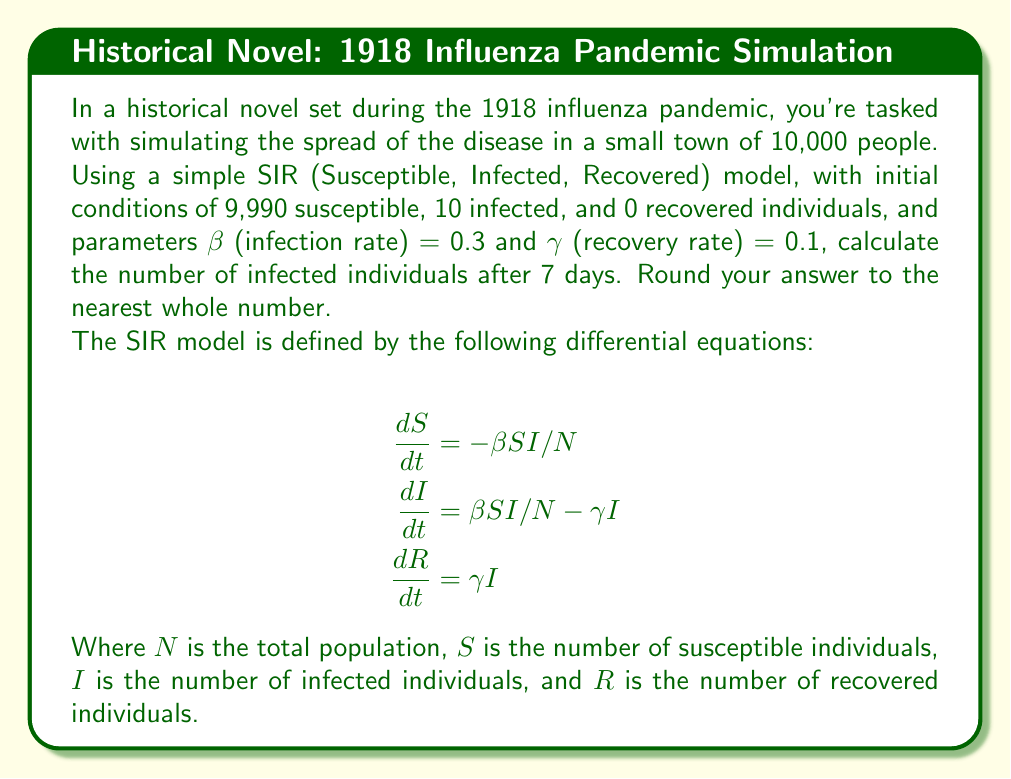Help me with this question. To solve this problem, we'll use a numerical method called Euler's method to approximate the solution to the differential equations. We'll use a time step of 1 day.

Step 1: Set up initial conditions and parameters
$S_0 = 9990$, $I_0 = 10$, $R_0 = 0$
$N = 10000$, $\beta = 0.3$, $\gamma = 0.1$
Time step $\Delta t = 1$ day, for 7 days

Step 2: Apply Euler's method for each day
For each day $t$, calculate:
$S_{t+1} = S_t + \Delta t \cdot (-\beta S_t I_t / N)$
$I_{t+1} = I_t + \Delta t \cdot (\beta S_t I_t / N - \gamma I_t)$
$R_{t+1} = R_t + \Delta t \cdot (\gamma I_t)$

Day 0: $S_0 = 9990$, $I_0 = 10$, $R_0 = 0$

Day 1:
$S_1 = 9990 + 1 \cdot (-0.3 \cdot 9990 \cdot 10 / 10000) = 9960.03$
$I_1 = 10 + 1 \cdot (0.3 \cdot 9990 \cdot 10 / 10000 - 0.1 \cdot 10) = 38.97$
$R_1 = 0 + 1 \cdot (0.1 \cdot 10) = 1$

Day 2:
$S_2 = 9960.03 + 1 \cdot (-0.3 \cdot 9960.03 \cdot 38.97 / 10000) = 9883.56$
$I_2 = 38.97 + 1 \cdot (0.3 \cdot 9960.03 \cdot 38.97 / 10000 - 0.1 \cdot 38.97) = 110.54$
$R_2 = 1 + 1 \cdot (0.1 \cdot 38.97) = 4.90$

Continuing this process for the remaining days:

Day 3: $S_3 = 9688.56$, $I_3 = 290.54$, $R_3 = 20.90$
Day 4: $S_4 = 9293.56$, $I_4 = 638.54$, $R_4 = 67.90$
Day 5: $S_5 = 8654.56$, $I_5 = 1173.54$, $R_5 = 171.90$
Day 6: $S_6 = 7803.56$, $I_6 = 1808.54$, $R_6 = 387.90$
Day 7: $S_7 = 6833.56$, $I_7 = 2420.54$, $R_7 = 745.90$

The number of infected individuals after 7 days is approximately 2420.54, which rounded to the nearest whole number is 2421.
Answer: 2421 